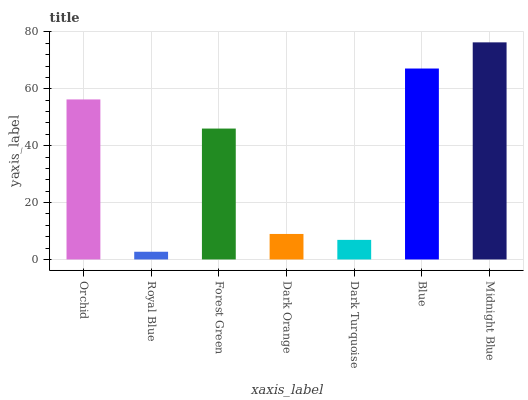Is Royal Blue the minimum?
Answer yes or no. Yes. Is Midnight Blue the maximum?
Answer yes or no. Yes. Is Forest Green the minimum?
Answer yes or no. No. Is Forest Green the maximum?
Answer yes or no. No. Is Forest Green greater than Royal Blue?
Answer yes or no. Yes. Is Royal Blue less than Forest Green?
Answer yes or no. Yes. Is Royal Blue greater than Forest Green?
Answer yes or no. No. Is Forest Green less than Royal Blue?
Answer yes or no. No. Is Forest Green the high median?
Answer yes or no. Yes. Is Forest Green the low median?
Answer yes or no. Yes. Is Dark Turquoise the high median?
Answer yes or no. No. Is Dark Turquoise the low median?
Answer yes or no. No. 